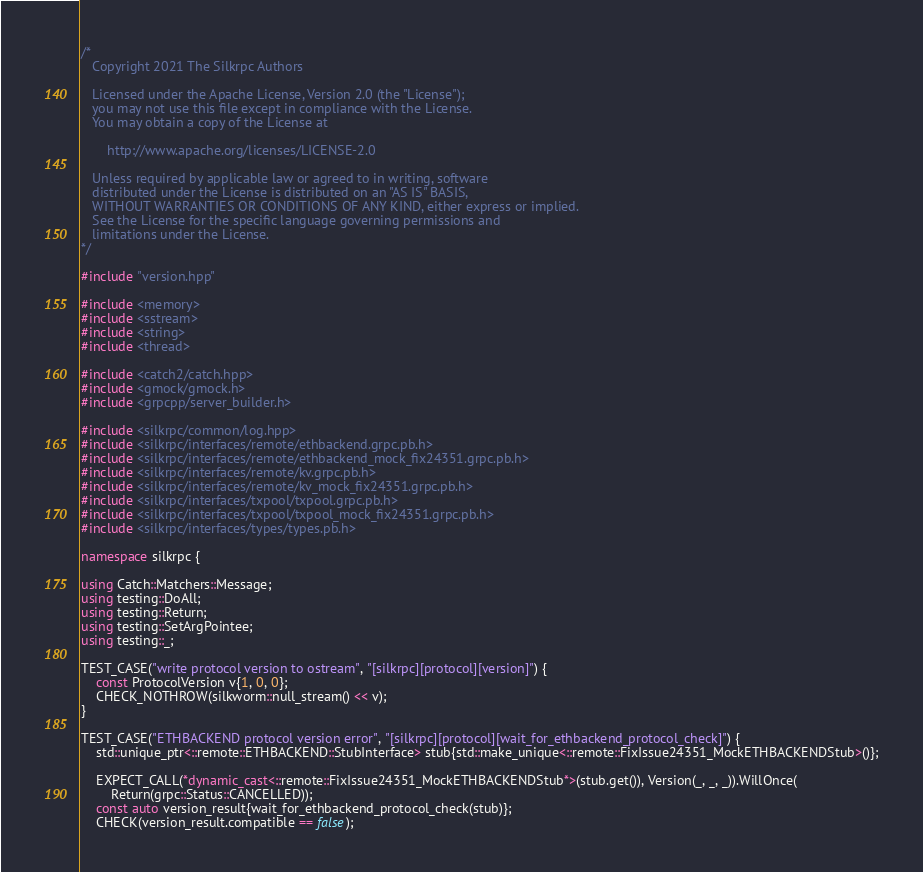Convert code to text. <code><loc_0><loc_0><loc_500><loc_500><_C++_>/*
   Copyright 2021 The Silkrpc Authors

   Licensed under the Apache License, Version 2.0 (the "License");
   you may not use this file except in compliance with the License.
   You may obtain a copy of the License at

       http://www.apache.org/licenses/LICENSE-2.0

   Unless required by applicable law or agreed to in writing, software
   distributed under the License is distributed on an "AS IS" BASIS,
   WITHOUT WARRANTIES OR CONDITIONS OF ANY KIND, either express or implied.
   See the License for the specific language governing permissions and
   limitations under the License.
*/

#include "version.hpp"

#include <memory>
#include <sstream>
#include <string>
#include <thread>

#include <catch2/catch.hpp>
#include <gmock/gmock.h>
#include <grpcpp/server_builder.h>

#include <silkrpc/common/log.hpp>
#include <silkrpc/interfaces/remote/ethbackend.grpc.pb.h>
#include <silkrpc/interfaces/remote/ethbackend_mock_fix24351.grpc.pb.h>
#include <silkrpc/interfaces/remote/kv.grpc.pb.h>
#include <silkrpc/interfaces/remote/kv_mock_fix24351.grpc.pb.h>
#include <silkrpc/interfaces/txpool/txpool.grpc.pb.h>
#include <silkrpc/interfaces/txpool/txpool_mock_fix24351.grpc.pb.h>
#include <silkrpc/interfaces/types/types.pb.h>

namespace silkrpc {

using Catch::Matchers::Message;
using testing::DoAll;
using testing::Return;
using testing::SetArgPointee;
using testing::_;

TEST_CASE("write protocol version to ostream", "[silkrpc][protocol][version]") {
    const ProtocolVersion v{1, 0, 0};
    CHECK_NOTHROW(silkworm::null_stream() << v);
}

TEST_CASE("ETHBACKEND protocol version error", "[silkrpc][protocol][wait_for_ethbackend_protocol_check]") {
    std::unique_ptr<::remote::ETHBACKEND::StubInterface> stub{std::make_unique<::remote::FixIssue24351_MockETHBACKENDStub>()};

    EXPECT_CALL(*dynamic_cast<::remote::FixIssue24351_MockETHBACKENDStub*>(stub.get()), Version(_, _, _)).WillOnce(
        Return(grpc::Status::CANCELLED));
    const auto version_result{wait_for_ethbackend_protocol_check(stub)};
    CHECK(version_result.compatible == false);</code> 